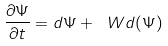Convert formula to latex. <formula><loc_0><loc_0><loc_500><loc_500>\frac { \partial \Psi } { \partial t } = \L d \Psi + \ W d ( \Psi )</formula> 